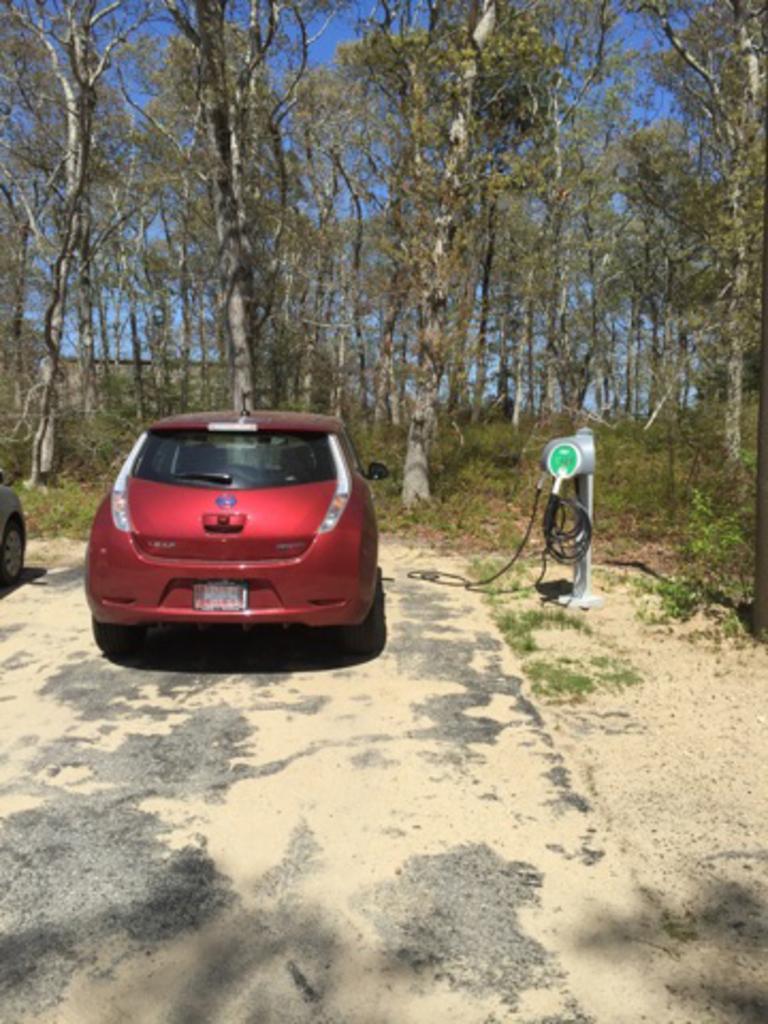Can you describe this image briefly? This picture shows a red color car and we see trees and another car on the side and we see grass on the ground and a blue sky. 